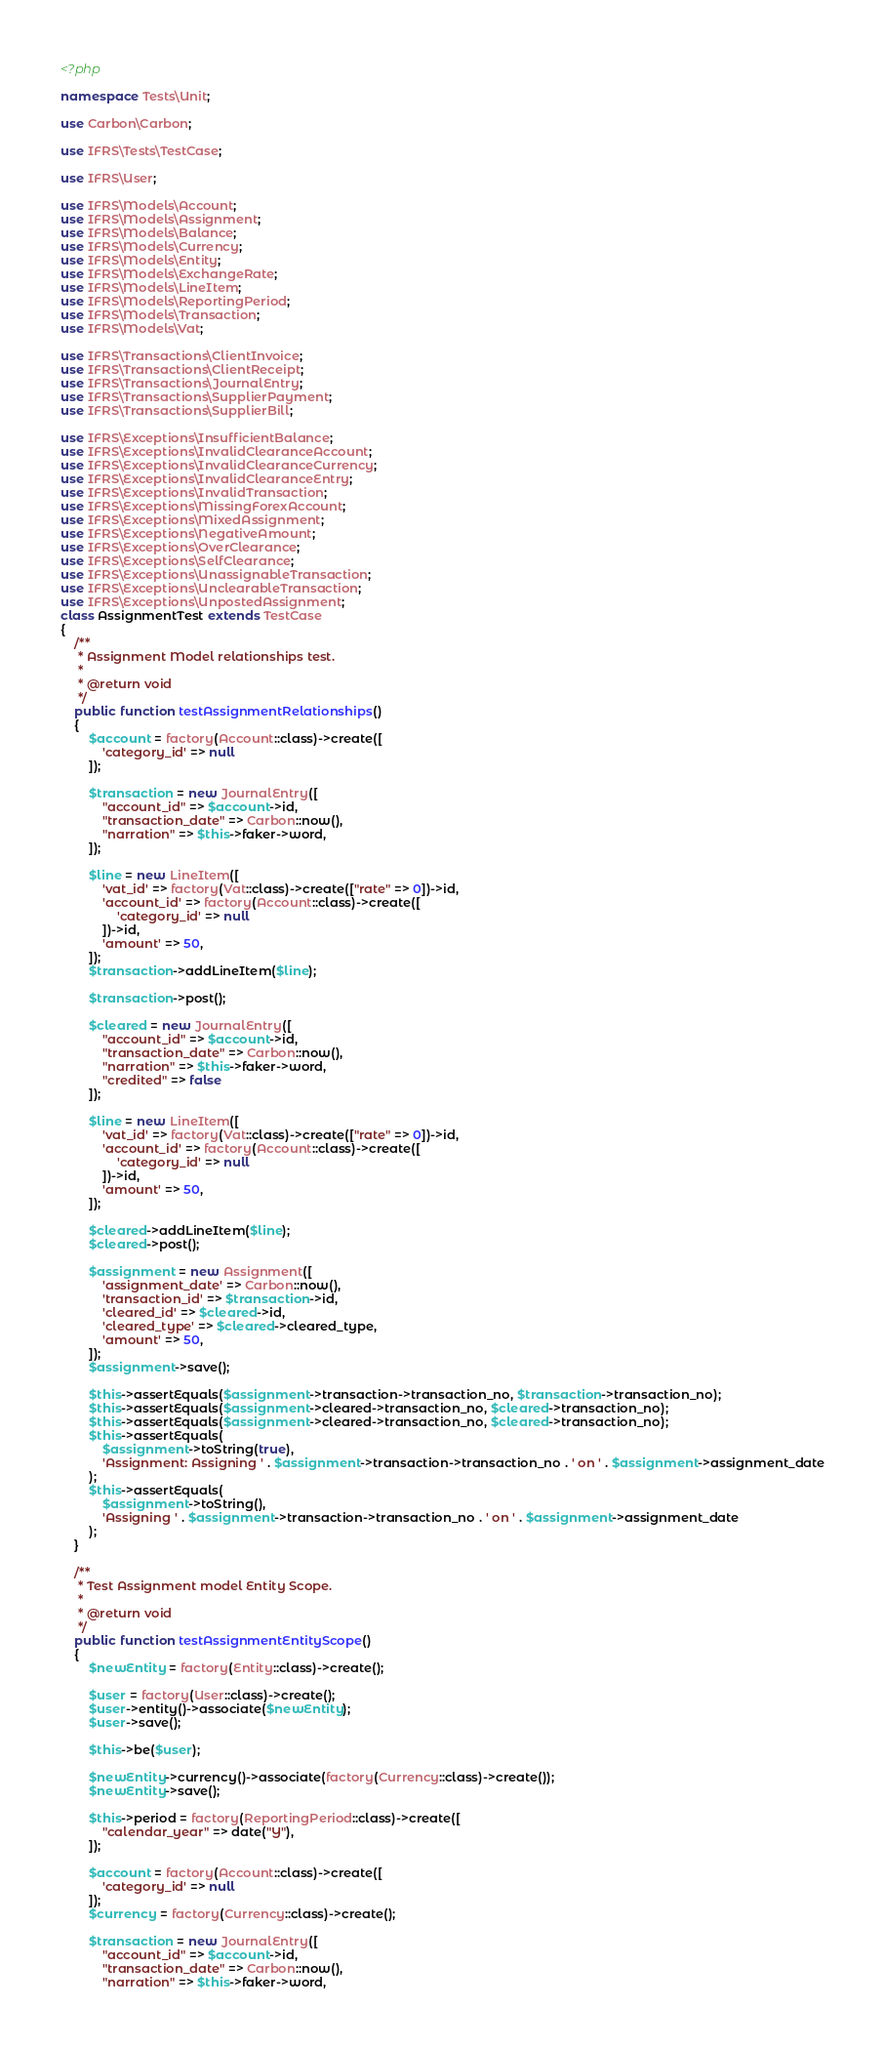Convert code to text. <code><loc_0><loc_0><loc_500><loc_500><_PHP_><?php

namespace Tests\Unit;

use Carbon\Carbon;

use IFRS\Tests\TestCase;

use IFRS\User;

use IFRS\Models\Account;
use IFRS\Models\Assignment;
use IFRS\Models\Balance;
use IFRS\Models\Currency;
use IFRS\Models\Entity;
use IFRS\Models\ExchangeRate;
use IFRS\Models\LineItem;
use IFRS\Models\ReportingPeriod;
use IFRS\Models\Transaction;
use IFRS\Models\Vat;

use IFRS\Transactions\ClientInvoice;
use IFRS\Transactions\ClientReceipt;
use IFRS\Transactions\JournalEntry;
use IFRS\Transactions\SupplierPayment;
use IFRS\Transactions\SupplierBill;

use IFRS\Exceptions\InsufficientBalance;
use IFRS\Exceptions\InvalidClearanceAccount;
use IFRS\Exceptions\InvalidClearanceCurrency;
use IFRS\Exceptions\InvalidClearanceEntry;
use IFRS\Exceptions\InvalidTransaction;
use IFRS\Exceptions\MissingForexAccount;
use IFRS\Exceptions\MixedAssignment;
use IFRS\Exceptions\NegativeAmount;
use IFRS\Exceptions\OverClearance;
use IFRS\Exceptions\SelfClearance;
use IFRS\Exceptions\UnassignableTransaction;
use IFRS\Exceptions\UnclearableTransaction;
use IFRS\Exceptions\UnpostedAssignment;
class AssignmentTest extends TestCase
{
    /**
     * Assignment Model relationships test.
     *
     * @return void
     */
    public function testAssignmentRelationships()
    {
        $account = factory(Account::class)->create([
            'category_id' => null
        ]);

        $transaction = new JournalEntry([
            "account_id" => $account->id,
            "transaction_date" => Carbon::now(),
            "narration" => $this->faker->word,
        ]);

        $line = new LineItem([
            'vat_id' => factory(Vat::class)->create(["rate" => 0])->id,
            'account_id' => factory(Account::class)->create([
                'category_id' => null
            ])->id,
            'amount' => 50,
        ]);
        $transaction->addLineItem($line);

        $transaction->post();

        $cleared = new JournalEntry([
            "account_id" => $account->id,
            "transaction_date" => Carbon::now(),
            "narration" => $this->faker->word,
            "credited" => false
        ]);

        $line = new LineItem([
            'vat_id' => factory(Vat::class)->create(["rate" => 0])->id,
            'account_id' => factory(Account::class)->create([
                'category_id' => null
            ])->id,
            'amount' => 50,
        ]);

        $cleared->addLineItem($line);
        $cleared->post();

        $assignment = new Assignment([
            'assignment_date' => Carbon::now(),
            'transaction_id' => $transaction->id,
            'cleared_id' => $cleared->id,
            'cleared_type' => $cleared->cleared_type,
            'amount' => 50,
        ]);
        $assignment->save();

        $this->assertEquals($assignment->transaction->transaction_no, $transaction->transaction_no);
        $this->assertEquals($assignment->cleared->transaction_no, $cleared->transaction_no);
        $this->assertEquals($assignment->cleared->transaction_no, $cleared->transaction_no);
        $this->assertEquals(
            $assignment->toString(true),
            'Assignment: Assigning ' . $assignment->transaction->transaction_no . ' on ' . $assignment->assignment_date
        );
        $this->assertEquals(
            $assignment->toString(),
            'Assigning ' . $assignment->transaction->transaction_no . ' on ' . $assignment->assignment_date
        );
    }

    /**
     * Test Assignment model Entity Scope.
     *
     * @return void
     */
    public function testAssignmentEntityScope()
    {
        $newEntity = factory(Entity::class)->create();

        $user = factory(User::class)->create();
        $user->entity()->associate($newEntity);
        $user->save();

        $this->be($user);

        $newEntity->currency()->associate(factory(Currency::class)->create());
        $newEntity->save();

        $this->period = factory(ReportingPeriod::class)->create([
            "calendar_year" => date("Y"),
        ]);

        $account = factory(Account::class)->create([
            'category_id' => null
        ]);
        $currency = factory(Currency::class)->create();

        $transaction = new JournalEntry([
            "account_id" => $account->id,
            "transaction_date" => Carbon::now(),
            "narration" => $this->faker->word,</code> 